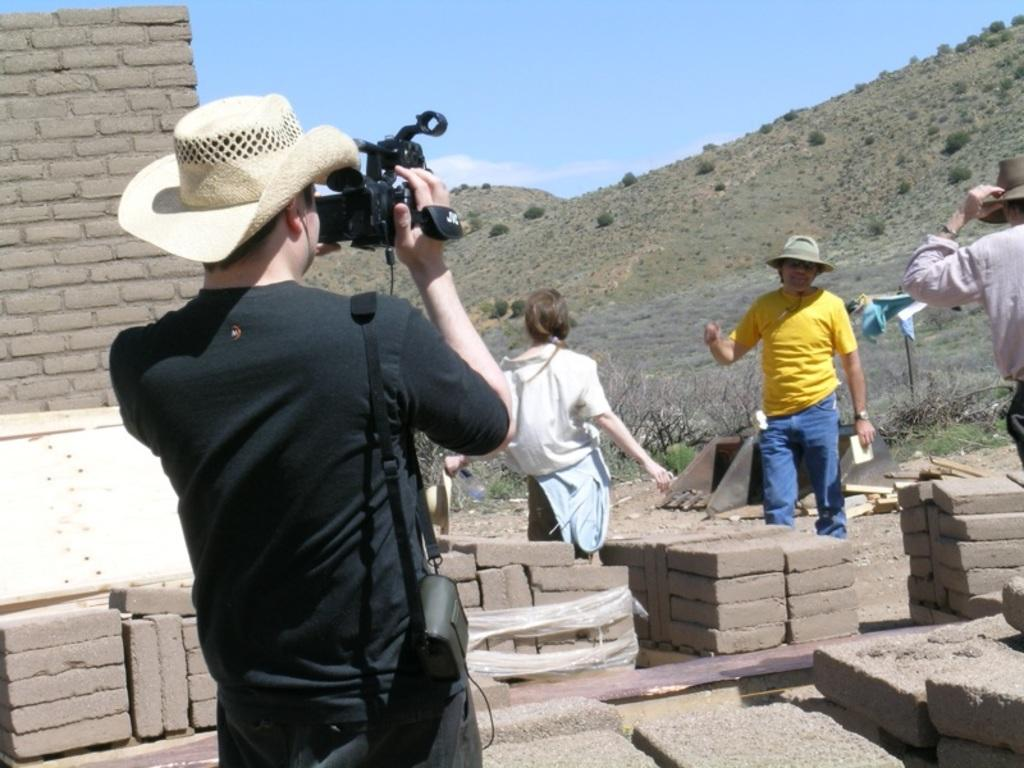How many people are in the group in the image? There is a group of people in the image, but the exact number is not specified. What is the man in the black t-shirt holding? The man in the black t-shirt is holding a camera. What is in front of the man with the camera? There are bricks and a wall in front of the man. What type of landscape can be seen in the image? Hills and plants are visible in the image, suggesting a natural landscape. What part of the natural environment is visible in the image? The sky is visible in the image. What type of ray is visible in the image? There is no ray visible in the image. How many copies of the picture are present in the image? There is no mention of a picture or copies in the image. 